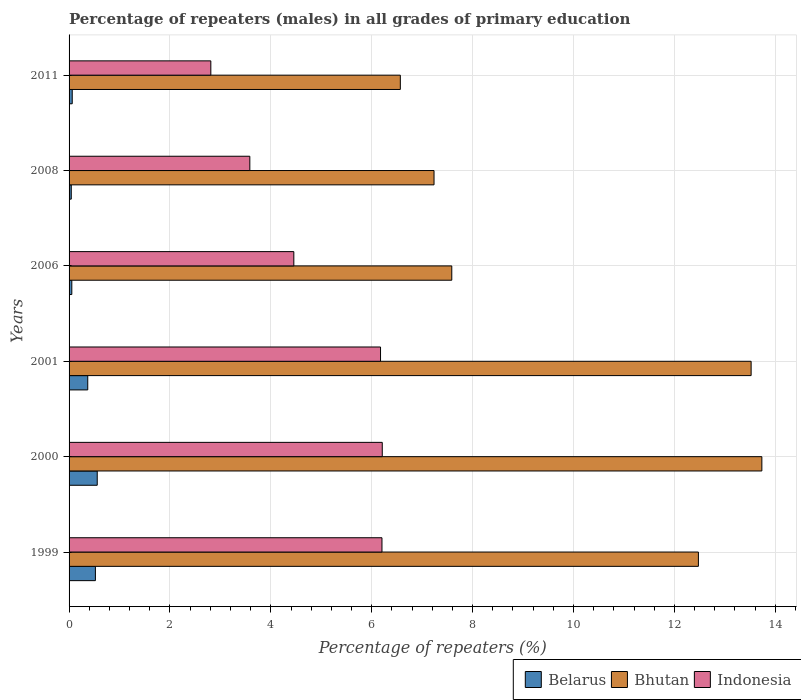How many different coloured bars are there?
Make the answer very short. 3. How many bars are there on the 5th tick from the top?
Your response must be concise. 3. How many bars are there on the 3rd tick from the bottom?
Your response must be concise. 3. What is the label of the 4th group of bars from the top?
Make the answer very short. 2001. What is the percentage of repeaters (males) in Bhutan in 2006?
Give a very brief answer. 7.59. Across all years, what is the maximum percentage of repeaters (males) in Bhutan?
Provide a short and direct response. 13.73. Across all years, what is the minimum percentage of repeaters (males) in Indonesia?
Ensure brevity in your answer.  2.81. What is the total percentage of repeaters (males) in Bhutan in the graph?
Your response must be concise. 61.12. What is the difference between the percentage of repeaters (males) in Belarus in 2000 and that in 2008?
Provide a short and direct response. 0.51. What is the difference between the percentage of repeaters (males) in Belarus in 2000 and the percentage of repeaters (males) in Bhutan in 1999?
Provide a short and direct response. -11.92. What is the average percentage of repeaters (males) in Bhutan per year?
Offer a terse response. 10.19. In the year 2000, what is the difference between the percentage of repeaters (males) in Belarus and percentage of repeaters (males) in Indonesia?
Offer a very short reply. -5.65. In how many years, is the percentage of repeaters (males) in Bhutan greater than 6.4 %?
Offer a terse response. 6. What is the ratio of the percentage of repeaters (males) in Indonesia in 2006 to that in 2008?
Give a very brief answer. 1.24. Is the difference between the percentage of repeaters (males) in Belarus in 1999 and 2008 greater than the difference between the percentage of repeaters (males) in Indonesia in 1999 and 2008?
Provide a short and direct response. No. What is the difference between the highest and the second highest percentage of repeaters (males) in Indonesia?
Keep it short and to the point. 0.01. What is the difference between the highest and the lowest percentage of repeaters (males) in Indonesia?
Your response must be concise. 3.4. What does the 2nd bar from the top in 2000 represents?
Your answer should be compact. Bhutan. What does the 1st bar from the bottom in 2006 represents?
Your response must be concise. Belarus. Is it the case that in every year, the sum of the percentage of repeaters (males) in Belarus and percentage of repeaters (males) in Indonesia is greater than the percentage of repeaters (males) in Bhutan?
Provide a succinct answer. No. How many bars are there?
Keep it short and to the point. 18. How many years are there in the graph?
Provide a short and direct response. 6. What is the difference between two consecutive major ticks on the X-axis?
Make the answer very short. 2. Does the graph contain any zero values?
Give a very brief answer. No. Does the graph contain grids?
Provide a short and direct response. Yes. How many legend labels are there?
Keep it short and to the point. 3. How are the legend labels stacked?
Make the answer very short. Horizontal. What is the title of the graph?
Make the answer very short. Percentage of repeaters (males) in all grades of primary education. Does "Moldova" appear as one of the legend labels in the graph?
Give a very brief answer. No. What is the label or title of the X-axis?
Give a very brief answer. Percentage of repeaters (%). What is the label or title of the Y-axis?
Give a very brief answer. Years. What is the Percentage of repeaters (%) in Belarus in 1999?
Make the answer very short. 0.52. What is the Percentage of repeaters (%) in Bhutan in 1999?
Your answer should be very brief. 12.48. What is the Percentage of repeaters (%) of Indonesia in 1999?
Offer a very short reply. 6.2. What is the Percentage of repeaters (%) of Belarus in 2000?
Ensure brevity in your answer.  0.56. What is the Percentage of repeaters (%) of Bhutan in 2000?
Make the answer very short. 13.73. What is the Percentage of repeaters (%) in Indonesia in 2000?
Your answer should be very brief. 6.21. What is the Percentage of repeaters (%) in Belarus in 2001?
Your response must be concise. 0.37. What is the Percentage of repeaters (%) of Bhutan in 2001?
Provide a short and direct response. 13.52. What is the Percentage of repeaters (%) in Indonesia in 2001?
Keep it short and to the point. 6.17. What is the Percentage of repeaters (%) of Belarus in 2006?
Your response must be concise. 0.05. What is the Percentage of repeaters (%) of Bhutan in 2006?
Make the answer very short. 7.59. What is the Percentage of repeaters (%) of Indonesia in 2006?
Make the answer very short. 4.46. What is the Percentage of repeaters (%) of Belarus in 2008?
Offer a terse response. 0.04. What is the Percentage of repeaters (%) of Bhutan in 2008?
Provide a short and direct response. 7.24. What is the Percentage of repeaters (%) of Indonesia in 2008?
Provide a succinct answer. 3.58. What is the Percentage of repeaters (%) in Belarus in 2011?
Make the answer very short. 0.06. What is the Percentage of repeaters (%) of Bhutan in 2011?
Your answer should be very brief. 6.57. What is the Percentage of repeaters (%) in Indonesia in 2011?
Your response must be concise. 2.81. Across all years, what is the maximum Percentage of repeaters (%) in Belarus?
Offer a terse response. 0.56. Across all years, what is the maximum Percentage of repeaters (%) of Bhutan?
Your answer should be compact. 13.73. Across all years, what is the maximum Percentage of repeaters (%) in Indonesia?
Ensure brevity in your answer.  6.21. Across all years, what is the minimum Percentage of repeaters (%) in Belarus?
Provide a succinct answer. 0.04. Across all years, what is the minimum Percentage of repeaters (%) of Bhutan?
Offer a very short reply. 6.57. Across all years, what is the minimum Percentage of repeaters (%) of Indonesia?
Your response must be concise. 2.81. What is the total Percentage of repeaters (%) in Belarus in the graph?
Provide a succinct answer. 1.61. What is the total Percentage of repeaters (%) in Bhutan in the graph?
Make the answer very short. 61.12. What is the total Percentage of repeaters (%) of Indonesia in the graph?
Give a very brief answer. 29.44. What is the difference between the Percentage of repeaters (%) in Belarus in 1999 and that in 2000?
Your answer should be compact. -0.04. What is the difference between the Percentage of repeaters (%) in Bhutan in 1999 and that in 2000?
Your answer should be compact. -1.26. What is the difference between the Percentage of repeaters (%) in Indonesia in 1999 and that in 2000?
Make the answer very short. -0.01. What is the difference between the Percentage of repeaters (%) in Belarus in 1999 and that in 2001?
Make the answer very short. 0.15. What is the difference between the Percentage of repeaters (%) of Bhutan in 1999 and that in 2001?
Provide a succinct answer. -1.05. What is the difference between the Percentage of repeaters (%) of Indonesia in 1999 and that in 2001?
Make the answer very short. 0.03. What is the difference between the Percentage of repeaters (%) of Belarus in 1999 and that in 2006?
Provide a succinct answer. 0.47. What is the difference between the Percentage of repeaters (%) in Bhutan in 1999 and that in 2006?
Offer a terse response. 4.89. What is the difference between the Percentage of repeaters (%) in Indonesia in 1999 and that in 2006?
Provide a short and direct response. 1.75. What is the difference between the Percentage of repeaters (%) in Belarus in 1999 and that in 2008?
Offer a terse response. 0.48. What is the difference between the Percentage of repeaters (%) of Bhutan in 1999 and that in 2008?
Provide a succinct answer. 5.24. What is the difference between the Percentage of repeaters (%) in Indonesia in 1999 and that in 2008?
Provide a short and direct response. 2.62. What is the difference between the Percentage of repeaters (%) of Belarus in 1999 and that in 2011?
Keep it short and to the point. 0.46. What is the difference between the Percentage of repeaters (%) of Bhutan in 1999 and that in 2011?
Offer a very short reply. 5.91. What is the difference between the Percentage of repeaters (%) in Indonesia in 1999 and that in 2011?
Give a very brief answer. 3.39. What is the difference between the Percentage of repeaters (%) in Belarus in 2000 and that in 2001?
Your answer should be compact. 0.19. What is the difference between the Percentage of repeaters (%) of Bhutan in 2000 and that in 2001?
Provide a short and direct response. 0.21. What is the difference between the Percentage of repeaters (%) in Indonesia in 2000 and that in 2001?
Your answer should be compact. 0.03. What is the difference between the Percentage of repeaters (%) of Belarus in 2000 and that in 2006?
Offer a very short reply. 0.5. What is the difference between the Percentage of repeaters (%) of Bhutan in 2000 and that in 2006?
Offer a very short reply. 6.15. What is the difference between the Percentage of repeaters (%) in Indonesia in 2000 and that in 2006?
Provide a short and direct response. 1.75. What is the difference between the Percentage of repeaters (%) in Belarus in 2000 and that in 2008?
Provide a succinct answer. 0.51. What is the difference between the Percentage of repeaters (%) of Bhutan in 2000 and that in 2008?
Offer a terse response. 6.5. What is the difference between the Percentage of repeaters (%) of Indonesia in 2000 and that in 2008?
Offer a terse response. 2.63. What is the difference between the Percentage of repeaters (%) of Belarus in 2000 and that in 2011?
Provide a succinct answer. 0.5. What is the difference between the Percentage of repeaters (%) in Bhutan in 2000 and that in 2011?
Your response must be concise. 7.17. What is the difference between the Percentage of repeaters (%) in Indonesia in 2000 and that in 2011?
Make the answer very short. 3.4. What is the difference between the Percentage of repeaters (%) in Belarus in 2001 and that in 2006?
Offer a terse response. 0.32. What is the difference between the Percentage of repeaters (%) of Bhutan in 2001 and that in 2006?
Your response must be concise. 5.93. What is the difference between the Percentage of repeaters (%) in Indonesia in 2001 and that in 2006?
Your answer should be very brief. 1.72. What is the difference between the Percentage of repeaters (%) in Belarus in 2001 and that in 2008?
Ensure brevity in your answer.  0.33. What is the difference between the Percentage of repeaters (%) of Bhutan in 2001 and that in 2008?
Your answer should be compact. 6.29. What is the difference between the Percentage of repeaters (%) of Indonesia in 2001 and that in 2008?
Keep it short and to the point. 2.59. What is the difference between the Percentage of repeaters (%) in Belarus in 2001 and that in 2011?
Provide a succinct answer. 0.31. What is the difference between the Percentage of repeaters (%) of Bhutan in 2001 and that in 2011?
Your answer should be very brief. 6.95. What is the difference between the Percentage of repeaters (%) in Indonesia in 2001 and that in 2011?
Your answer should be compact. 3.36. What is the difference between the Percentage of repeaters (%) of Belarus in 2006 and that in 2008?
Make the answer very short. 0.01. What is the difference between the Percentage of repeaters (%) of Bhutan in 2006 and that in 2008?
Make the answer very short. 0.35. What is the difference between the Percentage of repeaters (%) of Indonesia in 2006 and that in 2008?
Your answer should be compact. 0.87. What is the difference between the Percentage of repeaters (%) of Belarus in 2006 and that in 2011?
Give a very brief answer. -0.01. What is the difference between the Percentage of repeaters (%) in Indonesia in 2006 and that in 2011?
Provide a succinct answer. 1.65. What is the difference between the Percentage of repeaters (%) of Belarus in 2008 and that in 2011?
Make the answer very short. -0.02. What is the difference between the Percentage of repeaters (%) in Bhutan in 2008 and that in 2011?
Provide a short and direct response. 0.67. What is the difference between the Percentage of repeaters (%) in Indonesia in 2008 and that in 2011?
Keep it short and to the point. 0.77. What is the difference between the Percentage of repeaters (%) of Belarus in 1999 and the Percentage of repeaters (%) of Bhutan in 2000?
Your answer should be compact. -13.21. What is the difference between the Percentage of repeaters (%) of Belarus in 1999 and the Percentage of repeaters (%) of Indonesia in 2000?
Offer a terse response. -5.69. What is the difference between the Percentage of repeaters (%) in Bhutan in 1999 and the Percentage of repeaters (%) in Indonesia in 2000?
Provide a succinct answer. 6.27. What is the difference between the Percentage of repeaters (%) in Belarus in 1999 and the Percentage of repeaters (%) in Bhutan in 2001?
Keep it short and to the point. -13. What is the difference between the Percentage of repeaters (%) of Belarus in 1999 and the Percentage of repeaters (%) of Indonesia in 2001?
Your answer should be very brief. -5.65. What is the difference between the Percentage of repeaters (%) in Bhutan in 1999 and the Percentage of repeaters (%) in Indonesia in 2001?
Your response must be concise. 6.3. What is the difference between the Percentage of repeaters (%) of Belarus in 1999 and the Percentage of repeaters (%) of Bhutan in 2006?
Your response must be concise. -7.06. What is the difference between the Percentage of repeaters (%) in Belarus in 1999 and the Percentage of repeaters (%) in Indonesia in 2006?
Your answer should be compact. -3.93. What is the difference between the Percentage of repeaters (%) in Bhutan in 1999 and the Percentage of repeaters (%) in Indonesia in 2006?
Provide a succinct answer. 8.02. What is the difference between the Percentage of repeaters (%) in Belarus in 1999 and the Percentage of repeaters (%) in Bhutan in 2008?
Provide a succinct answer. -6.71. What is the difference between the Percentage of repeaters (%) in Belarus in 1999 and the Percentage of repeaters (%) in Indonesia in 2008?
Your answer should be compact. -3.06. What is the difference between the Percentage of repeaters (%) of Bhutan in 1999 and the Percentage of repeaters (%) of Indonesia in 2008?
Give a very brief answer. 8.89. What is the difference between the Percentage of repeaters (%) of Belarus in 1999 and the Percentage of repeaters (%) of Bhutan in 2011?
Give a very brief answer. -6.04. What is the difference between the Percentage of repeaters (%) of Belarus in 1999 and the Percentage of repeaters (%) of Indonesia in 2011?
Provide a short and direct response. -2.29. What is the difference between the Percentage of repeaters (%) in Bhutan in 1999 and the Percentage of repeaters (%) in Indonesia in 2011?
Ensure brevity in your answer.  9.67. What is the difference between the Percentage of repeaters (%) in Belarus in 2000 and the Percentage of repeaters (%) in Bhutan in 2001?
Keep it short and to the point. -12.96. What is the difference between the Percentage of repeaters (%) in Belarus in 2000 and the Percentage of repeaters (%) in Indonesia in 2001?
Offer a terse response. -5.62. What is the difference between the Percentage of repeaters (%) in Bhutan in 2000 and the Percentage of repeaters (%) in Indonesia in 2001?
Offer a very short reply. 7.56. What is the difference between the Percentage of repeaters (%) in Belarus in 2000 and the Percentage of repeaters (%) in Bhutan in 2006?
Provide a short and direct response. -7.03. What is the difference between the Percentage of repeaters (%) in Belarus in 2000 and the Percentage of repeaters (%) in Indonesia in 2006?
Your answer should be compact. -3.9. What is the difference between the Percentage of repeaters (%) of Bhutan in 2000 and the Percentage of repeaters (%) of Indonesia in 2006?
Your answer should be compact. 9.28. What is the difference between the Percentage of repeaters (%) in Belarus in 2000 and the Percentage of repeaters (%) in Bhutan in 2008?
Your answer should be very brief. -6.68. What is the difference between the Percentage of repeaters (%) of Belarus in 2000 and the Percentage of repeaters (%) of Indonesia in 2008?
Offer a very short reply. -3.03. What is the difference between the Percentage of repeaters (%) of Bhutan in 2000 and the Percentage of repeaters (%) of Indonesia in 2008?
Your answer should be compact. 10.15. What is the difference between the Percentage of repeaters (%) of Belarus in 2000 and the Percentage of repeaters (%) of Bhutan in 2011?
Your response must be concise. -6.01. What is the difference between the Percentage of repeaters (%) in Belarus in 2000 and the Percentage of repeaters (%) in Indonesia in 2011?
Your answer should be compact. -2.25. What is the difference between the Percentage of repeaters (%) of Bhutan in 2000 and the Percentage of repeaters (%) of Indonesia in 2011?
Offer a terse response. 10.92. What is the difference between the Percentage of repeaters (%) of Belarus in 2001 and the Percentage of repeaters (%) of Bhutan in 2006?
Your answer should be very brief. -7.22. What is the difference between the Percentage of repeaters (%) of Belarus in 2001 and the Percentage of repeaters (%) of Indonesia in 2006?
Your response must be concise. -4.09. What is the difference between the Percentage of repeaters (%) in Bhutan in 2001 and the Percentage of repeaters (%) in Indonesia in 2006?
Keep it short and to the point. 9.07. What is the difference between the Percentage of repeaters (%) of Belarus in 2001 and the Percentage of repeaters (%) of Bhutan in 2008?
Give a very brief answer. -6.86. What is the difference between the Percentage of repeaters (%) of Belarus in 2001 and the Percentage of repeaters (%) of Indonesia in 2008?
Your answer should be compact. -3.21. What is the difference between the Percentage of repeaters (%) in Bhutan in 2001 and the Percentage of repeaters (%) in Indonesia in 2008?
Make the answer very short. 9.94. What is the difference between the Percentage of repeaters (%) of Belarus in 2001 and the Percentage of repeaters (%) of Bhutan in 2011?
Give a very brief answer. -6.2. What is the difference between the Percentage of repeaters (%) in Belarus in 2001 and the Percentage of repeaters (%) in Indonesia in 2011?
Offer a very short reply. -2.44. What is the difference between the Percentage of repeaters (%) in Bhutan in 2001 and the Percentage of repeaters (%) in Indonesia in 2011?
Ensure brevity in your answer.  10.71. What is the difference between the Percentage of repeaters (%) of Belarus in 2006 and the Percentage of repeaters (%) of Bhutan in 2008?
Your answer should be very brief. -7.18. What is the difference between the Percentage of repeaters (%) in Belarus in 2006 and the Percentage of repeaters (%) in Indonesia in 2008?
Your answer should be very brief. -3.53. What is the difference between the Percentage of repeaters (%) of Bhutan in 2006 and the Percentage of repeaters (%) of Indonesia in 2008?
Your answer should be very brief. 4. What is the difference between the Percentage of repeaters (%) in Belarus in 2006 and the Percentage of repeaters (%) in Bhutan in 2011?
Your response must be concise. -6.51. What is the difference between the Percentage of repeaters (%) of Belarus in 2006 and the Percentage of repeaters (%) of Indonesia in 2011?
Provide a short and direct response. -2.76. What is the difference between the Percentage of repeaters (%) in Bhutan in 2006 and the Percentage of repeaters (%) in Indonesia in 2011?
Give a very brief answer. 4.78. What is the difference between the Percentage of repeaters (%) in Belarus in 2008 and the Percentage of repeaters (%) in Bhutan in 2011?
Offer a terse response. -6.52. What is the difference between the Percentage of repeaters (%) in Belarus in 2008 and the Percentage of repeaters (%) in Indonesia in 2011?
Provide a short and direct response. -2.77. What is the difference between the Percentage of repeaters (%) of Bhutan in 2008 and the Percentage of repeaters (%) of Indonesia in 2011?
Provide a succinct answer. 4.42. What is the average Percentage of repeaters (%) of Belarus per year?
Ensure brevity in your answer.  0.27. What is the average Percentage of repeaters (%) of Bhutan per year?
Ensure brevity in your answer.  10.19. What is the average Percentage of repeaters (%) in Indonesia per year?
Ensure brevity in your answer.  4.91. In the year 1999, what is the difference between the Percentage of repeaters (%) in Belarus and Percentage of repeaters (%) in Bhutan?
Offer a very short reply. -11.95. In the year 1999, what is the difference between the Percentage of repeaters (%) of Belarus and Percentage of repeaters (%) of Indonesia?
Make the answer very short. -5.68. In the year 1999, what is the difference between the Percentage of repeaters (%) in Bhutan and Percentage of repeaters (%) in Indonesia?
Keep it short and to the point. 6.27. In the year 2000, what is the difference between the Percentage of repeaters (%) in Belarus and Percentage of repeaters (%) in Bhutan?
Offer a terse response. -13.18. In the year 2000, what is the difference between the Percentage of repeaters (%) in Belarus and Percentage of repeaters (%) in Indonesia?
Offer a terse response. -5.65. In the year 2000, what is the difference between the Percentage of repeaters (%) in Bhutan and Percentage of repeaters (%) in Indonesia?
Provide a succinct answer. 7.53. In the year 2001, what is the difference between the Percentage of repeaters (%) in Belarus and Percentage of repeaters (%) in Bhutan?
Your answer should be compact. -13.15. In the year 2001, what is the difference between the Percentage of repeaters (%) of Belarus and Percentage of repeaters (%) of Indonesia?
Give a very brief answer. -5.8. In the year 2001, what is the difference between the Percentage of repeaters (%) in Bhutan and Percentage of repeaters (%) in Indonesia?
Offer a very short reply. 7.35. In the year 2006, what is the difference between the Percentage of repeaters (%) in Belarus and Percentage of repeaters (%) in Bhutan?
Provide a succinct answer. -7.53. In the year 2006, what is the difference between the Percentage of repeaters (%) in Belarus and Percentage of repeaters (%) in Indonesia?
Provide a short and direct response. -4.4. In the year 2006, what is the difference between the Percentage of repeaters (%) in Bhutan and Percentage of repeaters (%) in Indonesia?
Your response must be concise. 3.13. In the year 2008, what is the difference between the Percentage of repeaters (%) in Belarus and Percentage of repeaters (%) in Bhutan?
Your response must be concise. -7.19. In the year 2008, what is the difference between the Percentage of repeaters (%) in Belarus and Percentage of repeaters (%) in Indonesia?
Offer a very short reply. -3.54. In the year 2008, what is the difference between the Percentage of repeaters (%) in Bhutan and Percentage of repeaters (%) in Indonesia?
Your response must be concise. 3.65. In the year 2011, what is the difference between the Percentage of repeaters (%) of Belarus and Percentage of repeaters (%) of Bhutan?
Offer a terse response. -6.5. In the year 2011, what is the difference between the Percentage of repeaters (%) in Belarus and Percentage of repeaters (%) in Indonesia?
Provide a succinct answer. -2.75. In the year 2011, what is the difference between the Percentage of repeaters (%) in Bhutan and Percentage of repeaters (%) in Indonesia?
Your response must be concise. 3.76. What is the ratio of the Percentage of repeaters (%) of Belarus in 1999 to that in 2000?
Keep it short and to the point. 0.94. What is the ratio of the Percentage of repeaters (%) of Bhutan in 1999 to that in 2000?
Make the answer very short. 0.91. What is the ratio of the Percentage of repeaters (%) in Indonesia in 1999 to that in 2000?
Your answer should be compact. 1. What is the ratio of the Percentage of repeaters (%) of Belarus in 1999 to that in 2001?
Provide a short and direct response. 1.41. What is the ratio of the Percentage of repeaters (%) of Bhutan in 1999 to that in 2001?
Ensure brevity in your answer.  0.92. What is the ratio of the Percentage of repeaters (%) in Belarus in 1999 to that in 2006?
Ensure brevity in your answer.  9.59. What is the ratio of the Percentage of repeaters (%) of Bhutan in 1999 to that in 2006?
Keep it short and to the point. 1.64. What is the ratio of the Percentage of repeaters (%) of Indonesia in 1999 to that in 2006?
Make the answer very short. 1.39. What is the ratio of the Percentage of repeaters (%) of Belarus in 1999 to that in 2008?
Keep it short and to the point. 12.02. What is the ratio of the Percentage of repeaters (%) of Bhutan in 1999 to that in 2008?
Provide a short and direct response. 1.72. What is the ratio of the Percentage of repeaters (%) of Indonesia in 1999 to that in 2008?
Offer a terse response. 1.73. What is the ratio of the Percentage of repeaters (%) of Belarus in 1999 to that in 2011?
Your answer should be compact. 8.32. What is the ratio of the Percentage of repeaters (%) of Bhutan in 1999 to that in 2011?
Ensure brevity in your answer.  1.9. What is the ratio of the Percentage of repeaters (%) of Indonesia in 1999 to that in 2011?
Your answer should be compact. 2.21. What is the ratio of the Percentage of repeaters (%) of Belarus in 2000 to that in 2001?
Offer a very short reply. 1.51. What is the ratio of the Percentage of repeaters (%) in Bhutan in 2000 to that in 2001?
Ensure brevity in your answer.  1.02. What is the ratio of the Percentage of repeaters (%) in Belarus in 2000 to that in 2006?
Keep it short and to the point. 10.25. What is the ratio of the Percentage of repeaters (%) in Bhutan in 2000 to that in 2006?
Your answer should be very brief. 1.81. What is the ratio of the Percentage of repeaters (%) of Indonesia in 2000 to that in 2006?
Provide a short and direct response. 1.39. What is the ratio of the Percentage of repeaters (%) of Belarus in 2000 to that in 2008?
Give a very brief answer. 12.85. What is the ratio of the Percentage of repeaters (%) in Bhutan in 2000 to that in 2008?
Offer a very short reply. 1.9. What is the ratio of the Percentage of repeaters (%) in Indonesia in 2000 to that in 2008?
Keep it short and to the point. 1.73. What is the ratio of the Percentage of repeaters (%) of Belarus in 2000 to that in 2011?
Your answer should be compact. 8.9. What is the ratio of the Percentage of repeaters (%) in Bhutan in 2000 to that in 2011?
Offer a terse response. 2.09. What is the ratio of the Percentage of repeaters (%) in Indonesia in 2000 to that in 2011?
Provide a succinct answer. 2.21. What is the ratio of the Percentage of repeaters (%) of Belarus in 2001 to that in 2006?
Your answer should be very brief. 6.8. What is the ratio of the Percentage of repeaters (%) in Bhutan in 2001 to that in 2006?
Make the answer very short. 1.78. What is the ratio of the Percentage of repeaters (%) in Indonesia in 2001 to that in 2006?
Give a very brief answer. 1.39. What is the ratio of the Percentage of repeaters (%) in Belarus in 2001 to that in 2008?
Offer a very short reply. 8.53. What is the ratio of the Percentage of repeaters (%) of Bhutan in 2001 to that in 2008?
Provide a short and direct response. 1.87. What is the ratio of the Percentage of repeaters (%) in Indonesia in 2001 to that in 2008?
Give a very brief answer. 1.72. What is the ratio of the Percentage of repeaters (%) of Belarus in 2001 to that in 2011?
Provide a short and direct response. 5.91. What is the ratio of the Percentage of repeaters (%) in Bhutan in 2001 to that in 2011?
Give a very brief answer. 2.06. What is the ratio of the Percentage of repeaters (%) in Indonesia in 2001 to that in 2011?
Provide a succinct answer. 2.2. What is the ratio of the Percentage of repeaters (%) of Belarus in 2006 to that in 2008?
Your answer should be very brief. 1.25. What is the ratio of the Percentage of repeaters (%) of Bhutan in 2006 to that in 2008?
Your answer should be compact. 1.05. What is the ratio of the Percentage of repeaters (%) of Indonesia in 2006 to that in 2008?
Provide a short and direct response. 1.24. What is the ratio of the Percentage of repeaters (%) of Belarus in 2006 to that in 2011?
Keep it short and to the point. 0.87. What is the ratio of the Percentage of repeaters (%) of Bhutan in 2006 to that in 2011?
Offer a terse response. 1.16. What is the ratio of the Percentage of repeaters (%) in Indonesia in 2006 to that in 2011?
Offer a very short reply. 1.59. What is the ratio of the Percentage of repeaters (%) of Belarus in 2008 to that in 2011?
Offer a very short reply. 0.69. What is the ratio of the Percentage of repeaters (%) in Bhutan in 2008 to that in 2011?
Ensure brevity in your answer.  1.1. What is the ratio of the Percentage of repeaters (%) of Indonesia in 2008 to that in 2011?
Make the answer very short. 1.28. What is the difference between the highest and the second highest Percentage of repeaters (%) of Belarus?
Your response must be concise. 0.04. What is the difference between the highest and the second highest Percentage of repeaters (%) in Bhutan?
Your answer should be very brief. 0.21. What is the difference between the highest and the second highest Percentage of repeaters (%) of Indonesia?
Provide a succinct answer. 0.01. What is the difference between the highest and the lowest Percentage of repeaters (%) in Belarus?
Offer a very short reply. 0.51. What is the difference between the highest and the lowest Percentage of repeaters (%) of Bhutan?
Keep it short and to the point. 7.17. What is the difference between the highest and the lowest Percentage of repeaters (%) of Indonesia?
Provide a succinct answer. 3.4. 